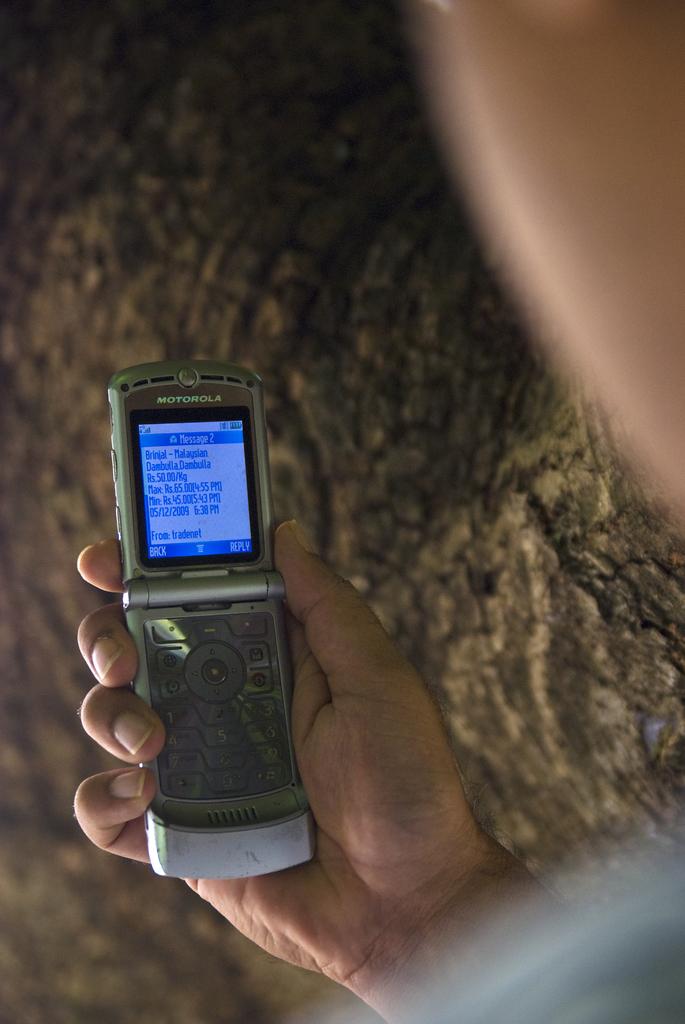Who makes this phone?
Give a very brief answer. Motorola. What message number is this?
Provide a short and direct response. 2. 